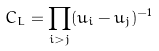Convert formula to latex. <formula><loc_0><loc_0><loc_500><loc_500>C _ { L } = \prod _ { i > j } ( u _ { i } - u _ { j } ) ^ { - 1 }</formula> 